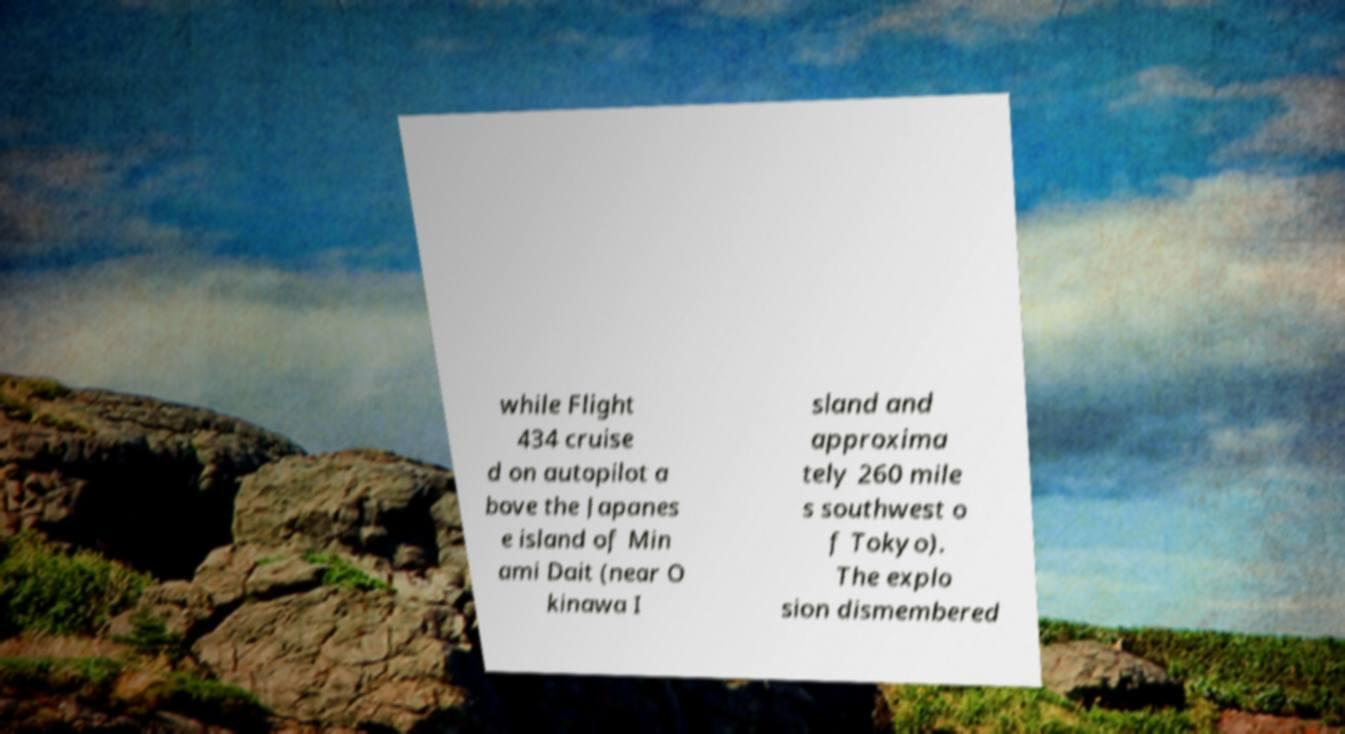What messages or text are displayed in this image? I need them in a readable, typed format. while Flight 434 cruise d on autopilot a bove the Japanes e island of Min ami Dait (near O kinawa I sland and approxima tely 260 mile s southwest o f Tokyo). The explo sion dismembered 